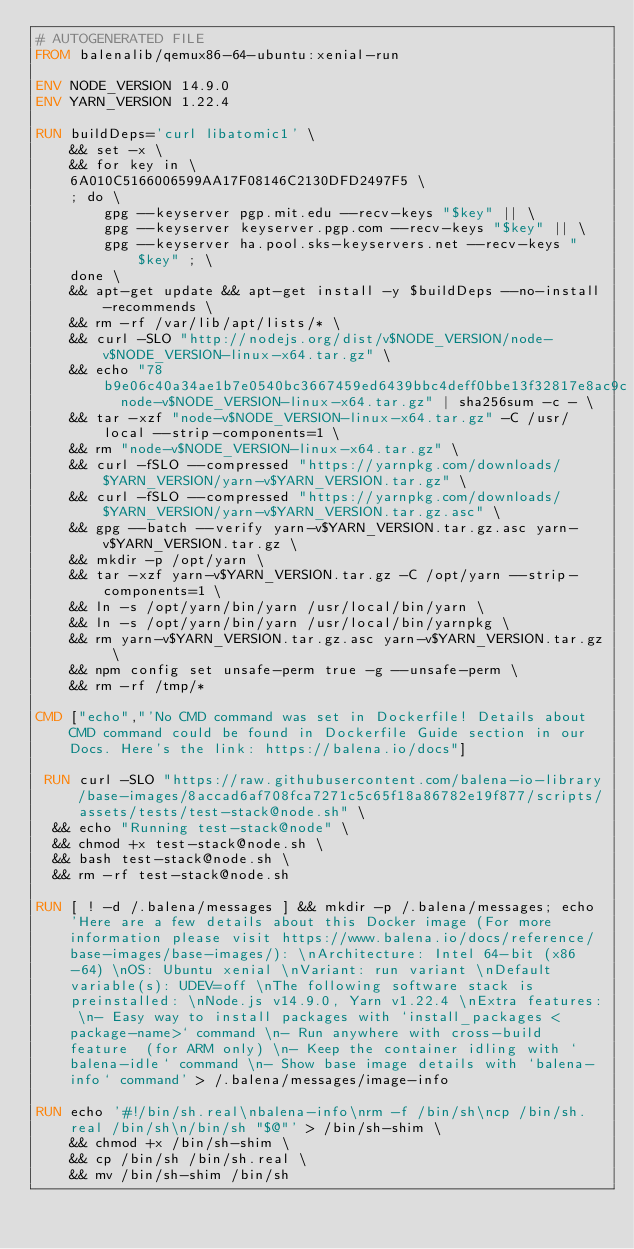Convert code to text. <code><loc_0><loc_0><loc_500><loc_500><_Dockerfile_># AUTOGENERATED FILE
FROM balenalib/qemux86-64-ubuntu:xenial-run

ENV NODE_VERSION 14.9.0
ENV YARN_VERSION 1.22.4

RUN buildDeps='curl libatomic1' \
	&& set -x \
	&& for key in \
	6A010C5166006599AA17F08146C2130DFD2497F5 \
	; do \
		gpg --keyserver pgp.mit.edu --recv-keys "$key" || \
		gpg --keyserver keyserver.pgp.com --recv-keys "$key" || \
		gpg --keyserver ha.pool.sks-keyservers.net --recv-keys "$key" ; \
	done \
	&& apt-get update && apt-get install -y $buildDeps --no-install-recommends \
	&& rm -rf /var/lib/apt/lists/* \
	&& curl -SLO "http://nodejs.org/dist/v$NODE_VERSION/node-v$NODE_VERSION-linux-x64.tar.gz" \
	&& echo "78b9e06c40a34ae1b7e0540bc3667459ed6439bbc4deff0bbe13f32817e8ac9c  node-v$NODE_VERSION-linux-x64.tar.gz" | sha256sum -c - \
	&& tar -xzf "node-v$NODE_VERSION-linux-x64.tar.gz" -C /usr/local --strip-components=1 \
	&& rm "node-v$NODE_VERSION-linux-x64.tar.gz" \
	&& curl -fSLO --compressed "https://yarnpkg.com/downloads/$YARN_VERSION/yarn-v$YARN_VERSION.tar.gz" \
	&& curl -fSLO --compressed "https://yarnpkg.com/downloads/$YARN_VERSION/yarn-v$YARN_VERSION.tar.gz.asc" \
	&& gpg --batch --verify yarn-v$YARN_VERSION.tar.gz.asc yarn-v$YARN_VERSION.tar.gz \
	&& mkdir -p /opt/yarn \
	&& tar -xzf yarn-v$YARN_VERSION.tar.gz -C /opt/yarn --strip-components=1 \
	&& ln -s /opt/yarn/bin/yarn /usr/local/bin/yarn \
	&& ln -s /opt/yarn/bin/yarn /usr/local/bin/yarnpkg \
	&& rm yarn-v$YARN_VERSION.tar.gz.asc yarn-v$YARN_VERSION.tar.gz \
	&& npm config set unsafe-perm true -g --unsafe-perm \
	&& rm -rf /tmp/*

CMD ["echo","'No CMD command was set in Dockerfile! Details about CMD command could be found in Dockerfile Guide section in our Docs. Here's the link: https://balena.io/docs"]

 RUN curl -SLO "https://raw.githubusercontent.com/balena-io-library/base-images/8accad6af708fca7271c5c65f18a86782e19f877/scripts/assets/tests/test-stack@node.sh" \
  && echo "Running test-stack@node" \
  && chmod +x test-stack@node.sh \
  && bash test-stack@node.sh \
  && rm -rf test-stack@node.sh 

RUN [ ! -d /.balena/messages ] && mkdir -p /.balena/messages; echo 'Here are a few details about this Docker image (For more information please visit https://www.balena.io/docs/reference/base-images/base-images/): \nArchitecture: Intel 64-bit (x86-64) \nOS: Ubuntu xenial \nVariant: run variant \nDefault variable(s): UDEV=off \nThe following software stack is preinstalled: \nNode.js v14.9.0, Yarn v1.22.4 \nExtra features: \n- Easy way to install packages with `install_packages <package-name>` command \n- Run anywhere with cross-build feature  (for ARM only) \n- Keep the container idling with `balena-idle` command \n- Show base image details with `balena-info` command' > /.balena/messages/image-info

RUN echo '#!/bin/sh.real\nbalena-info\nrm -f /bin/sh\ncp /bin/sh.real /bin/sh\n/bin/sh "$@"' > /bin/sh-shim \
	&& chmod +x /bin/sh-shim \
	&& cp /bin/sh /bin/sh.real \
	&& mv /bin/sh-shim /bin/sh</code> 